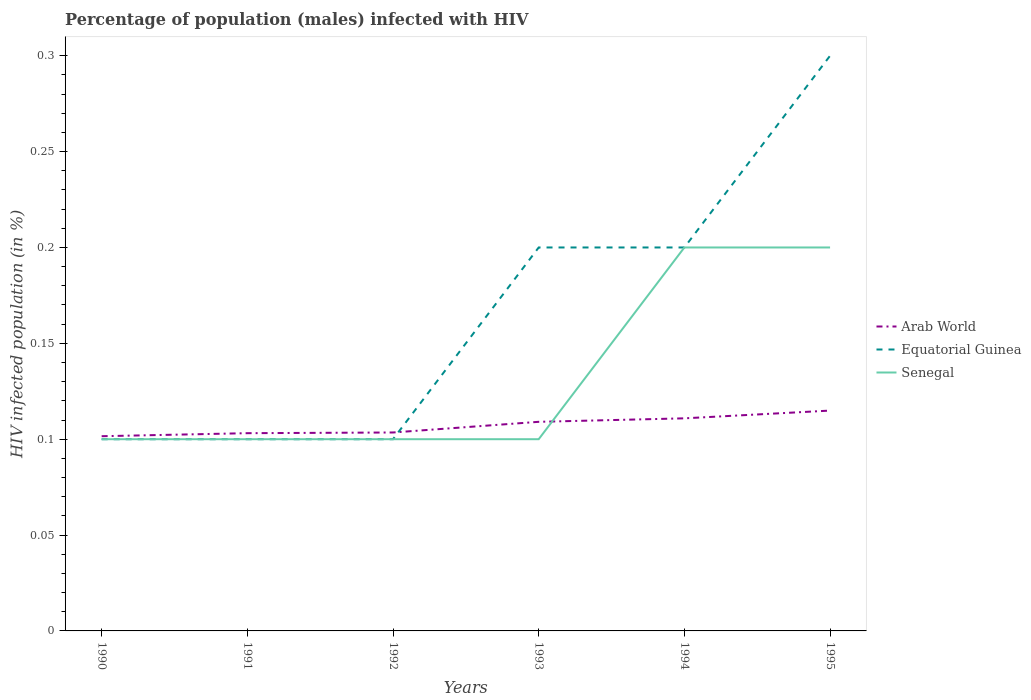How many different coloured lines are there?
Your answer should be compact. 3. Is the number of lines equal to the number of legend labels?
Ensure brevity in your answer.  Yes. In which year was the percentage of HIV infected male population in Equatorial Guinea maximum?
Ensure brevity in your answer.  1990. What is the total percentage of HIV infected male population in Equatorial Guinea in the graph?
Ensure brevity in your answer.  -0.1. What is the difference between the highest and the second highest percentage of HIV infected male population in Equatorial Guinea?
Provide a short and direct response. 0.2. What is the difference between the highest and the lowest percentage of HIV infected male population in Arab World?
Your response must be concise. 3. How many years are there in the graph?
Your response must be concise. 6. What is the difference between two consecutive major ticks on the Y-axis?
Make the answer very short. 0.05. Are the values on the major ticks of Y-axis written in scientific E-notation?
Your answer should be compact. No. Where does the legend appear in the graph?
Offer a very short reply. Center right. What is the title of the graph?
Give a very brief answer. Percentage of population (males) infected with HIV. What is the label or title of the Y-axis?
Offer a terse response. HIV infected population (in %). What is the HIV infected population (in %) of Arab World in 1990?
Provide a succinct answer. 0.1. What is the HIV infected population (in %) in Arab World in 1991?
Your answer should be compact. 0.1. What is the HIV infected population (in %) in Equatorial Guinea in 1991?
Your answer should be very brief. 0.1. What is the HIV infected population (in %) of Senegal in 1991?
Keep it short and to the point. 0.1. What is the HIV infected population (in %) of Arab World in 1992?
Offer a very short reply. 0.1. What is the HIV infected population (in %) of Equatorial Guinea in 1992?
Your answer should be very brief. 0.1. What is the HIV infected population (in %) in Senegal in 1992?
Keep it short and to the point. 0.1. What is the HIV infected population (in %) in Arab World in 1993?
Give a very brief answer. 0.11. What is the HIV infected population (in %) of Arab World in 1994?
Keep it short and to the point. 0.11. What is the HIV infected population (in %) in Equatorial Guinea in 1994?
Your answer should be very brief. 0.2. What is the HIV infected population (in %) in Arab World in 1995?
Your response must be concise. 0.11. What is the HIV infected population (in %) in Senegal in 1995?
Your answer should be compact. 0.2. Across all years, what is the maximum HIV infected population (in %) in Arab World?
Offer a terse response. 0.11. Across all years, what is the maximum HIV infected population (in %) in Senegal?
Your answer should be very brief. 0.2. Across all years, what is the minimum HIV infected population (in %) of Arab World?
Your answer should be very brief. 0.1. Across all years, what is the minimum HIV infected population (in %) in Equatorial Guinea?
Provide a short and direct response. 0.1. Across all years, what is the minimum HIV infected population (in %) of Senegal?
Your answer should be compact. 0.1. What is the total HIV infected population (in %) of Arab World in the graph?
Make the answer very short. 0.64. What is the total HIV infected population (in %) of Equatorial Guinea in the graph?
Give a very brief answer. 1. What is the difference between the HIV infected population (in %) in Arab World in 1990 and that in 1991?
Give a very brief answer. -0. What is the difference between the HIV infected population (in %) in Senegal in 1990 and that in 1991?
Keep it short and to the point. 0. What is the difference between the HIV infected population (in %) of Arab World in 1990 and that in 1992?
Offer a very short reply. -0. What is the difference between the HIV infected population (in %) of Arab World in 1990 and that in 1993?
Offer a very short reply. -0.01. What is the difference between the HIV infected population (in %) of Equatorial Guinea in 1990 and that in 1993?
Give a very brief answer. -0.1. What is the difference between the HIV infected population (in %) in Senegal in 1990 and that in 1993?
Keep it short and to the point. 0. What is the difference between the HIV infected population (in %) in Arab World in 1990 and that in 1994?
Provide a short and direct response. -0.01. What is the difference between the HIV infected population (in %) in Equatorial Guinea in 1990 and that in 1994?
Provide a short and direct response. -0.1. What is the difference between the HIV infected population (in %) in Arab World in 1990 and that in 1995?
Provide a short and direct response. -0.01. What is the difference between the HIV infected population (in %) of Equatorial Guinea in 1990 and that in 1995?
Your answer should be compact. -0.2. What is the difference between the HIV infected population (in %) in Arab World in 1991 and that in 1992?
Ensure brevity in your answer.  -0. What is the difference between the HIV infected population (in %) in Arab World in 1991 and that in 1993?
Provide a succinct answer. -0.01. What is the difference between the HIV infected population (in %) in Senegal in 1991 and that in 1993?
Give a very brief answer. 0. What is the difference between the HIV infected population (in %) in Arab World in 1991 and that in 1994?
Ensure brevity in your answer.  -0.01. What is the difference between the HIV infected population (in %) in Senegal in 1991 and that in 1994?
Provide a short and direct response. -0.1. What is the difference between the HIV infected population (in %) of Arab World in 1991 and that in 1995?
Ensure brevity in your answer.  -0.01. What is the difference between the HIV infected population (in %) in Equatorial Guinea in 1991 and that in 1995?
Your answer should be very brief. -0.2. What is the difference between the HIV infected population (in %) in Arab World in 1992 and that in 1993?
Provide a short and direct response. -0.01. What is the difference between the HIV infected population (in %) of Arab World in 1992 and that in 1994?
Keep it short and to the point. -0.01. What is the difference between the HIV infected population (in %) in Equatorial Guinea in 1992 and that in 1994?
Keep it short and to the point. -0.1. What is the difference between the HIV infected population (in %) of Arab World in 1992 and that in 1995?
Make the answer very short. -0.01. What is the difference between the HIV infected population (in %) of Arab World in 1993 and that in 1994?
Give a very brief answer. -0. What is the difference between the HIV infected population (in %) of Senegal in 1993 and that in 1994?
Keep it short and to the point. -0.1. What is the difference between the HIV infected population (in %) of Arab World in 1993 and that in 1995?
Your answer should be very brief. -0.01. What is the difference between the HIV infected population (in %) of Equatorial Guinea in 1993 and that in 1995?
Ensure brevity in your answer.  -0.1. What is the difference between the HIV infected population (in %) of Arab World in 1994 and that in 1995?
Your answer should be very brief. -0. What is the difference between the HIV infected population (in %) of Equatorial Guinea in 1994 and that in 1995?
Keep it short and to the point. -0.1. What is the difference between the HIV infected population (in %) of Senegal in 1994 and that in 1995?
Ensure brevity in your answer.  0. What is the difference between the HIV infected population (in %) in Arab World in 1990 and the HIV infected population (in %) in Equatorial Guinea in 1991?
Provide a short and direct response. 0. What is the difference between the HIV infected population (in %) in Arab World in 1990 and the HIV infected population (in %) in Senegal in 1991?
Your response must be concise. 0. What is the difference between the HIV infected population (in %) in Equatorial Guinea in 1990 and the HIV infected population (in %) in Senegal in 1991?
Your answer should be compact. 0. What is the difference between the HIV infected population (in %) of Arab World in 1990 and the HIV infected population (in %) of Equatorial Guinea in 1992?
Give a very brief answer. 0. What is the difference between the HIV infected population (in %) in Arab World in 1990 and the HIV infected population (in %) in Senegal in 1992?
Give a very brief answer. 0. What is the difference between the HIV infected population (in %) of Equatorial Guinea in 1990 and the HIV infected population (in %) of Senegal in 1992?
Give a very brief answer. 0. What is the difference between the HIV infected population (in %) in Arab World in 1990 and the HIV infected population (in %) in Equatorial Guinea in 1993?
Your response must be concise. -0.1. What is the difference between the HIV infected population (in %) of Arab World in 1990 and the HIV infected population (in %) of Senegal in 1993?
Offer a very short reply. 0. What is the difference between the HIV infected population (in %) of Equatorial Guinea in 1990 and the HIV infected population (in %) of Senegal in 1993?
Offer a terse response. 0. What is the difference between the HIV infected population (in %) of Arab World in 1990 and the HIV infected population (in %) of Equatorial Guinea in 1994?
Offer a very short reply. -0.1. What is the difference between the HIV infected population (in %) in Arab World in 1990 and the HIV infected population (in %) in Senegal in 1994?
Offer a terse response. -0.1. What is the difference between the HIV infected population (in %) of Arab World in 1990 and the HIV infected population (in %) of Equatorial Guinea in 1995?
Your response must be concise. -0.2. What is the difference between the HIV infected population (in %) of Arab World in 1990 and the HIV infected population (in %) of Senegal in 1995?
Ensure brevity in your answer.  -0.1. What is the difference between the HIV infected population (in %) of Arab World in 1991 and the HIV infected population (in %) of Equatorial Guinea in 1992?
Your answer should be compact. 0. What is the difference between the HIV infected population (in %) in Arab World in 1991 and the HIV infected population (in %) in Senegal in 1992?
Provide a short and direct response. 0. What is the difference between the HIV infected population (in %) of Arab World in 1991 and the HIV infected population (in %) of Equatorial Guinea in 1993?
Offer a terse response. -0.1. What is the difference between the HIV infected population (in %) in Arab World in 1991 and the HIV infected population (in %) in Senegal in 1993?
Offer a terse response. 0. What is the difference between the HIV infected population (in %) in Equatorial Guinea in 1991 and the HIV infected population (in %) in Senegal in 1993?
Ensure brevity in your answer.  0. What is the difference between the HIV infected population (in %) in Arab World in 1991 and the HIV infected population (in %) in Equatorial Guinea in 1994?
Provide a short and direct response. -0.1. What is the difference between the HIV infected population (in %) in Arab World in 1991 and the HIV infected population (in %) in Senegal in 1994?
Give a very brief answer. -0.1. What is the difference between the HIV infected population (in %) in Arab World in 1991 and the HIV infected population (in %) in Equatorial Guinea in 1995?
Provide a short and direct response. -0.2. What is the difference between the HIV infected population (in %) of Arab World in 1991 and the HIV infected population (in %) of Senegal in 1995?
Make the answer very short. -0.1. What is the difference between the HIV infected population (in %) in Arab World in 1992 and the HIV infected population (in %) in Equatorial Guinea in 1993?
Offer a terse response. -0.1. What is the difference between the HIV infected population (in %) in Arab World in 1992 and the HIV infected population (in %) in Senegal in 1993?
Keep it short and to the point. 0. What is the difference between the HIV infected population (in %) in Equatorial Guinea in 1992 and the HIV infected population (in %) in Senegal in 1993?
Your answer should be compact. 0. What is the difference between the HIV infected population (in %) of Arab World in 1992 and the HIV infected population (in %) of Equatorial Guinea in 1994?
Your response must be concise. -0.1. What is the difference between the HIV infected population (in %) of Arab World in 1992 and the HIV infected population (in %) of Senegal in 1994?
Provide a short and direct response. -0.1. What is the difference between the HIV infected population (in %) in Arab World in 1992 and the HIV infected population (in %) in Equatorial Guinea in 1995?
Make the answer very short. -0.2. What is the difference between the HIV infected population (in %) of Arab World in 1992 and the HIV infected population (in %) of Senegal in 1995?
Give a very brief answer. -0.1. What is the difference between the HIV infected population (in %) of Equatorial Guinea in 1992 and the HIV infected population (in %) of Senegal in 1995?
Offer a very short reply. -0.1. What is the difference between the HIV infected population (in %) of Arab World in 1993 and the HIV infected population (in %) of Equatorial Guinea in 1994?
Offer a very short reply. -0.09. What is the difference between the HIV infected population (in %) in Arab World in 1993 and the HIV infected population (in %) in Senegal in 1994?
Offer a very short reply. -0.09. What is the difference between the HIV infected population (in %) of Equatorial Guinea in 1993 and the HIV infected population (in %) of Senegal in 1994?
Your answer should be compact. 0. What is the difference between the HIV infected population (in %) in Arab World in 1993 and the HIV infected population (in %) in Equatorial Guinea in 1995?
Give a very brief answer. -0.19. What is the difference between the HIV infected population (in %) in Arab World in 1993 and the HIV infected population (in %) in Senegal in 1995?
Provide a short and direct response. -0.09. What is the difference between the HIV infected population (in %) of Arab World in 1994 and the HIV infected population (in %) of Equatorial Guinea in 1995?
Give a very brief answer. -0.19. What is the difference between the HIV infected population (in %) in Arab World in 1994 and the HIV infected population (in %) in Senegal in 1995?
Offer a terse response. -0.09. What is the difference between the HIV infected population (in %) in Equatorial Guinea in 1994 and the HIV infected population (in %) in Senegal in 1995?
Ensure brevity in your answer.  0. What is the average HIV infected population (in %) in Arab World per year?
Offer a terse response. 0.11. What is the average HIV infected population (in %) of Senegal per year?
Ensure brevity in your answer.  0.13. In the year 1990, what is the difference between the HIV infected population (in %) in Arab World and HIV infected population (in %) in Equatorial Guinea?
Provide a succinct answer. 0. In the year 1990, what is the difference between the HIV infected population (in %) in Arab World and HIV infected population (in %) in Senegal?
Give a very brief answer. 0. In the year 1990, what is the difference between the HIV infected population (in %) of Equatorial Guinea and HIV infected population (in %) of Senegal?
Offer a terse response. 0. In the year 1991, what is the difference between the HIV infected population (in %) of Arab World and HIV infected population (in %) of Equatorial Guinea?
Provide a succinct answer. 0. In the year 1991, what is the difference between the HIV infected population (in %) of Arab World and HIV infected population (in %) of Senegal?
Your response must be concise. 0. In the year 1991, what is the difference between the HIV infected population (in %) of Equatorial Guinea and HIV infected population (in %) of Senegal?
Offer a very short reply. 0. In the year 1992, what is the difference between the HIV infected population (in %) of Arab World and HIV infected population (in %) of Equatorial Guinea?
Your answer should be very brief. 0. In the year 1992, what is the difference between the HIV infected population (in %) of Arab World and HIV infected population (in %) of Senegal?
Provide a succinct answer. 0. In the year 1993, what is the difference between the HIV infected population (in %) of Arab World and HIV infected population (in %) of Equatorial Guinea?
Ensure brevity in your answer.  -0.09. In the year 1993, what is the difference between the HIV infected population (in %) in Arab World and HIV infected population (in %) in Senegal?
Provide a short and direct response. 0.01. In the year 1993, what is the difference between the HIV infected population (in %) in Equatorial Guinea and HIV infected population (in %) in Senegal?
Give a very brief answer. 0.1. In the year 1994, what is the difference between the HIV infected population (in %) of Arab World and HIV infected population (in %) of Equatorial Guinea?
Provide a short and direct response. -0.09. In the year 1994, what is the difference between the HIV infected population (in %) of Arab World and HIV infected population (in %) of Senegal?
Give a very brief answer. -0.09. In the year 1995, what is the difference between the HIV infected population (in %) in Arab World and HIV infected population (in %) in Equatorial Guinea?
Make the answer very short. -0.19. In the year 1995, what is the difference between the HIV infected population (in %) of Arab World and HIV infected population (in %) of Senegal?
Keep it short and to the point. -0.09. In the year 1995, what is the difference between the HIV infected population (in %) of Equatorial Guinea and HIV infected population (in %) of Senegal?
Make the answer very short. 0.1. What is the ratio of the HIV infected population (in %) in Arab World in 1990 to that in 1991?
Keep it short and to the point. 0.98. What is the ratio of the HIV infected population (in %) in Equatorial Guinea in 1990 to that in 1991?
Offer a very short reply. 1. What is the ratio of the HIV infected population (in %) in Senegal in 1990 to that in 1991?
Give a very brief answer. 1. What is the ratio of the HIV infected population (in %) of Arab World in 1990 to that in 1992?
Your response must be concise. 0.98. What is the ratio of the HIV infected population (in %) of Arab World in 1990 to that in 1993?
Provide a short and direct response. 0.93. What is the ratio of the HIV infected population (in %) of Equatorial Guinea in 1990 to that in 1993?
Ensure brevity in your answer.  0.5. What is the ratio of the HIV infected population (in %) of Arab World in 1990 to that in 1994?
Make the answer very short. 0.92. What is the ratio of the HIV infected population (in %) in Senegal in 1990 to that in 1994?
Give a very brief answer. 0.5. What is the ratio of the HIV infected population (in %) of Arab World in 1990 to that in 1995?
Keep it short and to the point. 0.88. What is the ratio of the HIV infected population (in %) of Equatorial Guinea in 1990 to that in 1995?
Your answer should be very brief. 0.33. What is the ratio of the HIV infected population (in %) in Arab World in 1991 to that in 1993?
Give a very brief answer. 0.95. What is the ratio of the HIV infected population (in %) of Senegal in 1991 to that in 1993?
Give a very brief answer. 1. What is the ratio of the HIV infected population (in %) of Arab World in 1991 to that in 1994?
Your answer should be compact. 0.93. What is the ratio of the HIV infected population (in %) of Senegal in 1991 to that in 1994?
Provide a succinct answer. 0.5. What is the ratio of the HIV infected population (in %) of Arab World in 1991 to that in 1995?
Give a very brief answer. 0.9. What is the ratio of the HIV infected population (in %) of Equatorial Guinea in 1991 to that in 1995?
Ensure brevity in your answer.  0.33. What is the ratio of the HIV infected population (in %) of Arab World in 1992 to that in 1993?
Offer a very short reply. 0.95. What is the ratio of the HIV infected population (in %) of Equatorial Guinea in 1992 to that in 1993?
Your answer should be compact. 0.5. What is the ratio of the HIV infected population (in %) of Arab World in 1992 to that in 1994?
Ensure brevity in your answer.  0.93. What is the ratio of the HIV infected population (in %) in Senegal in 1992 to that in 1994?
Provide a short and direct response. 0.5. What is the ratio of the HIV infected population (in %) in Arab World in 1992 to that in 1995?
Ensure brevity in your answer.  0.9. What is the ratio of the HIV infected population (in %) of Equatorial Guinea in 1992 to that in 1995?
Your answer should be very brief. 0.33. What is the ratio of the HIV infected population (in %) of Senegal in 1992 to that in 1995?
Your response must be concise. 0.5. What is the ratio of the HIV infected population (in %) in Arab World in 1993 to that in 1994?
Offer a terse response. 0.98. What is the ratio of the HIV infected population (in %) of Arab World in 1993 to that in 1995?
Your answer should be very brief. 0.95. What is the ratio of the HIV infected population (in %) in Equatorial Guinea in 1993 to that in 1995?
Provide a succinct answer. 0.67. What is the ratio of the HIV infected population (in %) in Arab World in 1994 to that in 1995?
Give a very brief answer. 0.96. What is the ratio of the HIV infected population (in %) in Equatorial Guinea in 1994 to that in 1995?
Your answer should be compact. 0.67. What is the ratio of the HIV infected population (in %) in Senegal in 1994 to that in 1995?
Give a very brief answer. 1. What is the difference between the highest and the second highest HIV infected population (in %) in Arab World?
Give a very brief answer. 0. What is the difference between the highest and the second highest HIV infected population (in %) of Senegal?
Your response must be concise. 0. What is the difference between the highest and the lowest HIV infected population (in %) of Arab World?
Ensure brevity in your answer.  0.01. What is the difference between the highest and the lowest HIV infected population (in %) of Equatorial Guinea?
Offer a terse response. 0.2. 